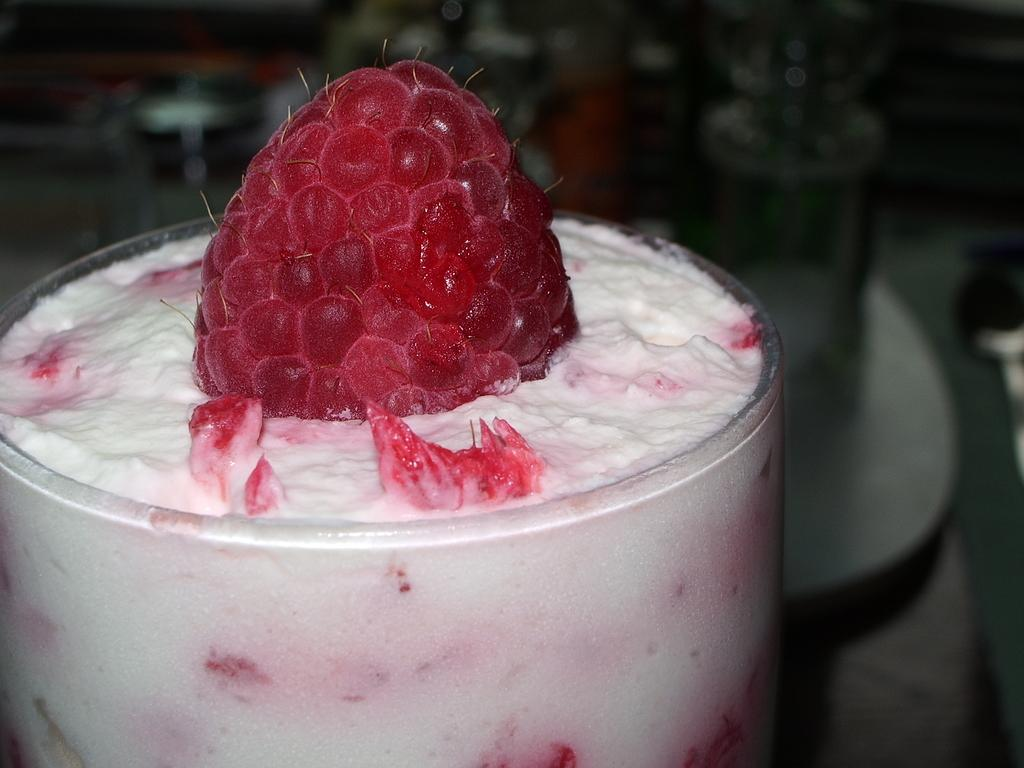What object is present in the image that is typically used for drinking? There is a glass in the image. What is inside the glass? There is something in the glass. How many cakes are on the table next to the glass in the image? There is no table or cakes mentioned in the image; only a glass is present. What does the egg taste like in the image? There is no egg present in the image, so it is not possible to determine its taste. 